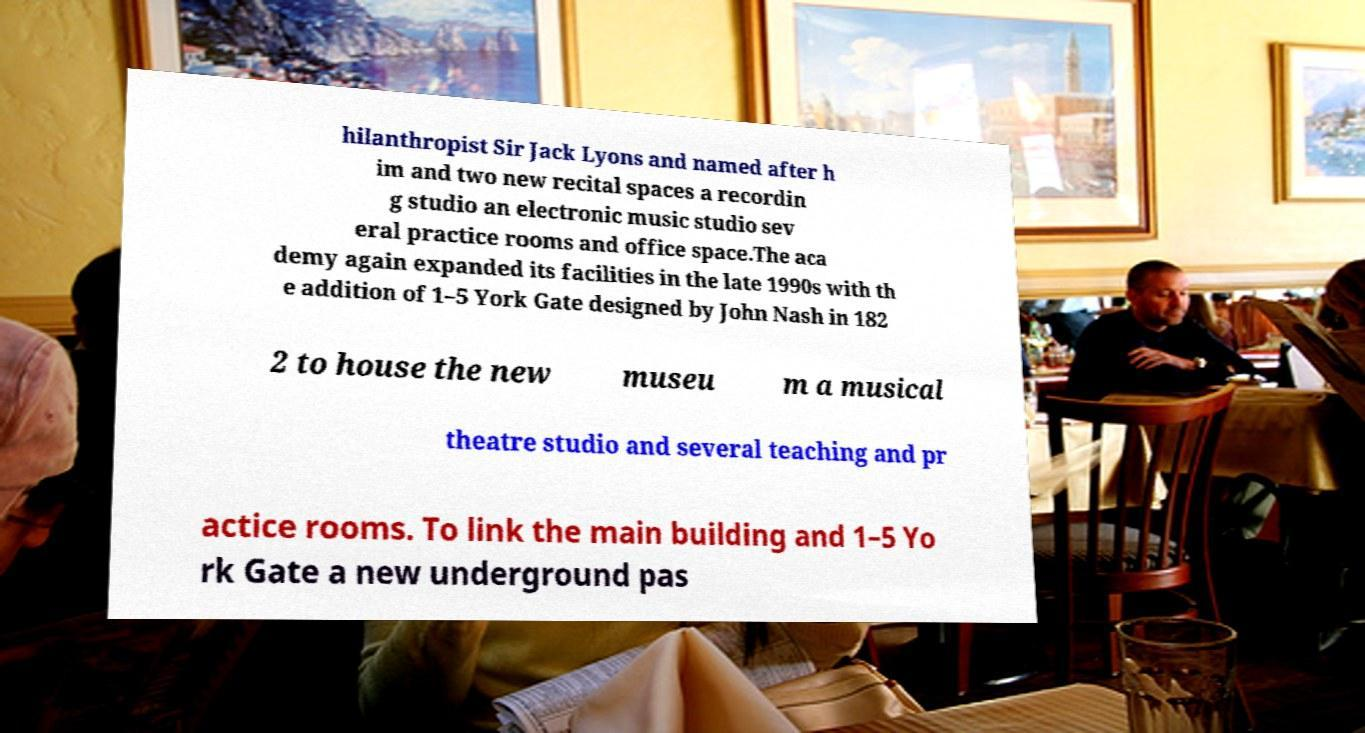What messages or text are displayed in this image? I need them in a readable, typed format. hilanthropist Sir Jack Lyons and named after h im and two new recital spaces a recordin g studio an electronic music studio sev eral practice rooms and office space.The aca demy again expanded its facilities in the late 1990s with th e addition of 1–5 York Gate designed by John Nash in 182 2 to house the new museu m a musical theatre studio and several teaching and pr actice rooms. To link the main building and 1–5 Yo rk Gate a new underground pas 